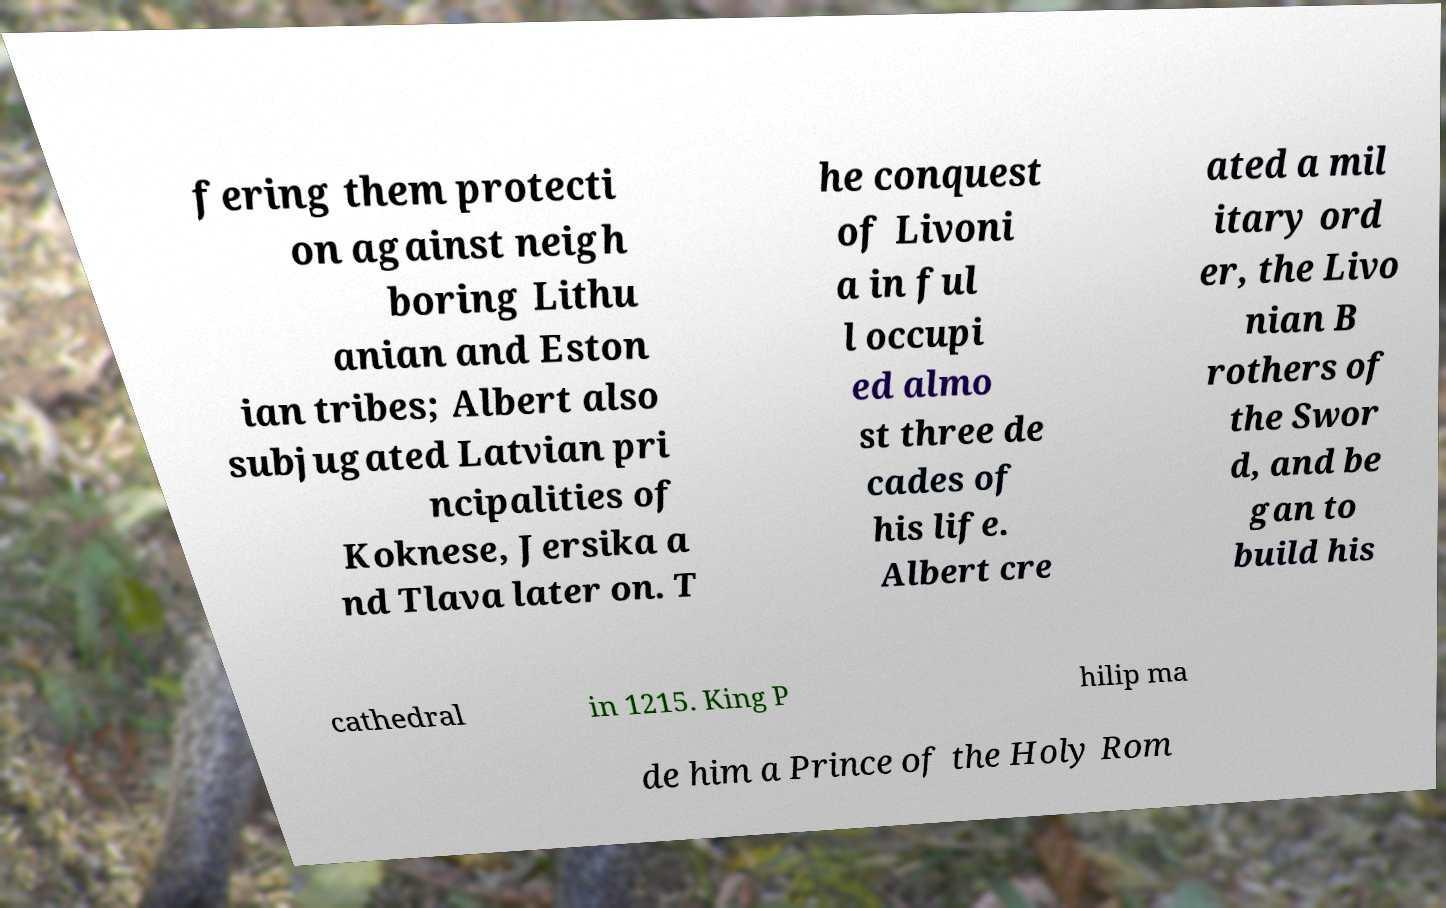Please identify and transcribe the text found in this image. fering them protecti on against neigh boring Lithu anian and Eston ian tribes; Albert also subjugated Latvian pri ncipalities of Koknese, Jersika a nd Tlava later on. T he conquest of Livoni a in ful l occupi ed almo st three de cades of his life. Albert cre ated a mil itary ord er, the Livo nian B rothers of the Swor d, and be gan to build his cathedral in 1215. King P hilip ma de him a Prince of the Holy Rom 